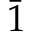<formula> <loc_0><loc_0><loc_500><loc_500>\bar { 1 }</formula> 